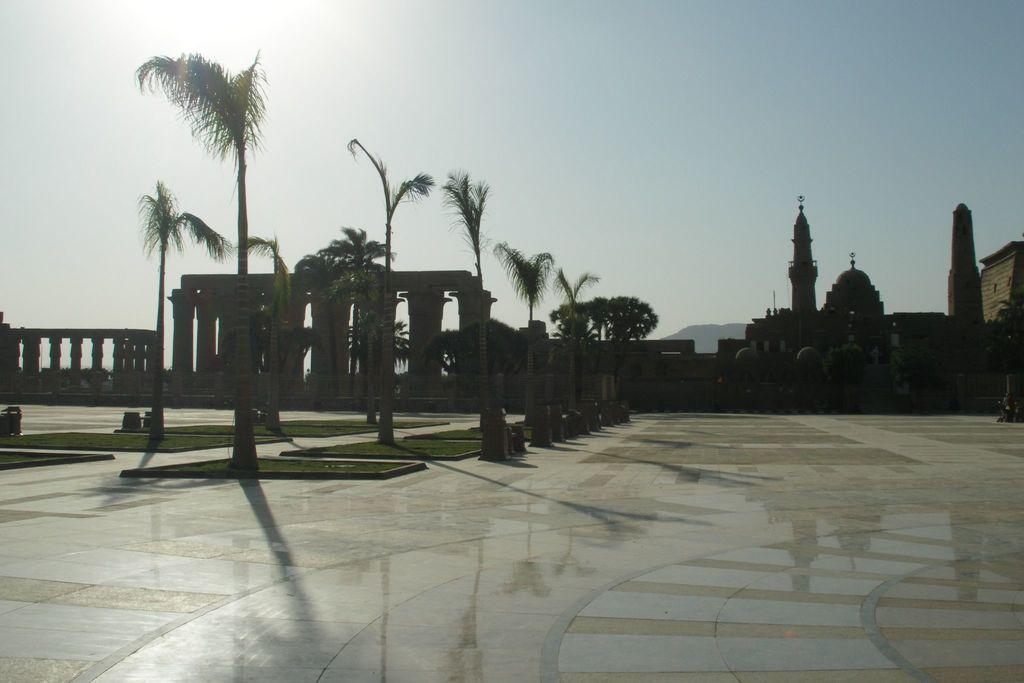What type of structures can be seen in the image? There are buildings in the image. What architectural elements are present in the image? There are pillars in the image. What type of vegetation is visible in the image? There are trees and plants in the image. What is the surface on which the buildings and vegetation are situated? The ground is visible in the image, and grass is present on the ground. What else can be seen on the ground in the image? There are objects on the ground. What part of the natural environment is visible in the image? The sky is visible in the image. What is the opinion of the trees in the image? Trees do not have opinions, as they are inanimate objects. Can you see anyone jumping in the image? There is no indication of anyone jumping in the image. Is there a gun visible in the image? There is no gun present in the image. 